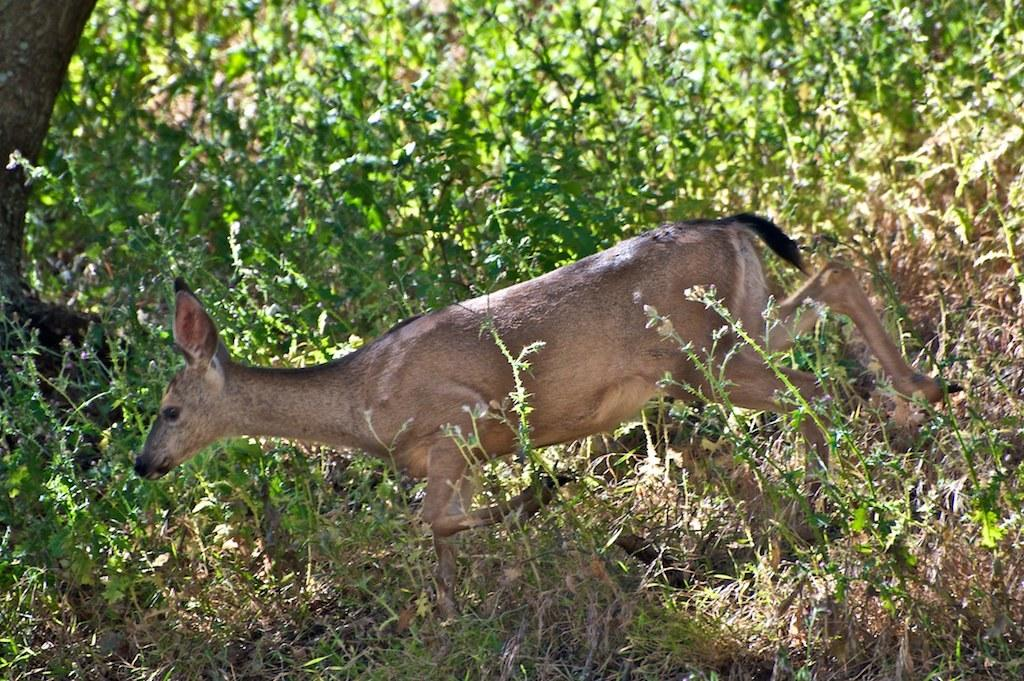What is the main subject in the center of the image? There is a deer in the center of the image. What can be seen in the surroundings of the deer? There are plants around the area of the image. What type of behavior is the deer exhibiting in the image? The image does not provide information about the deer's behavior, so it cannot be determined from the image. 